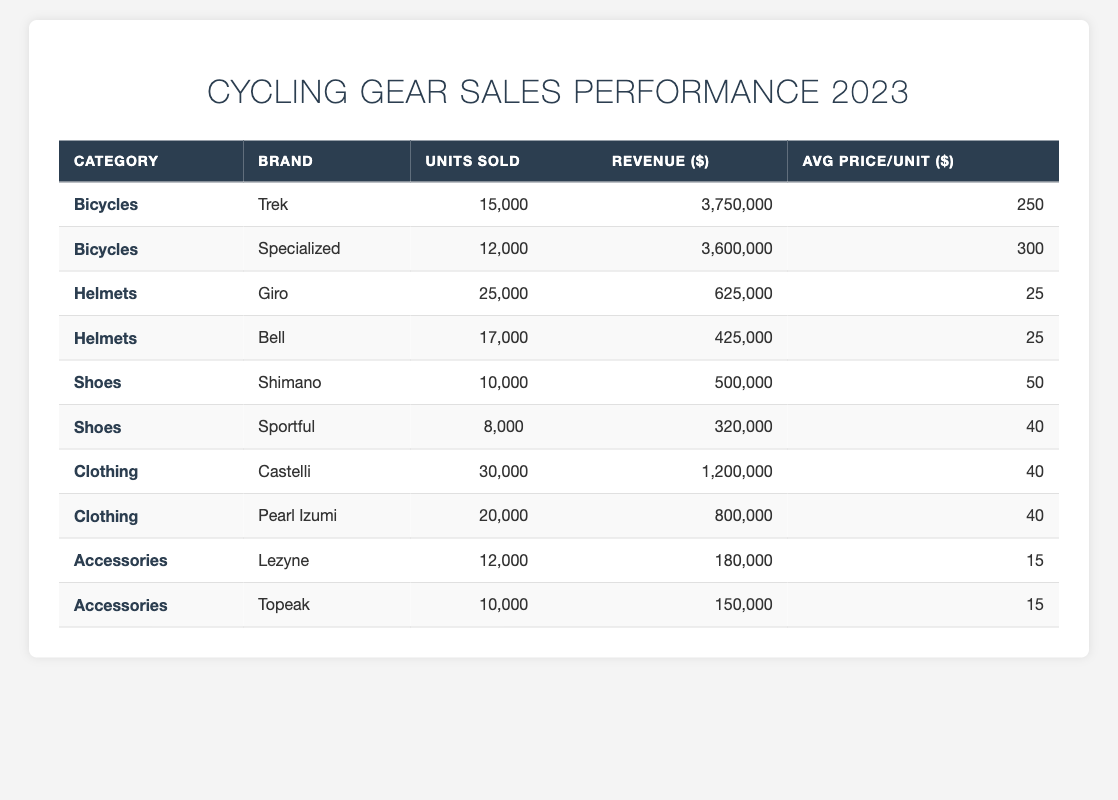What is the total revenue generated from bicycle sales? The revenues for bicycles sold are $3,750,000 (Trek) + $3,600,000 (Specialized) = $7,350,000.
Answer: $7,350,000 Which brand sold the most units of helmets? Giro sold 25,000 units, whereas Bell sold 17,000 units. Therefore, Giro sold the most helmets.
Answer: Giro What was the average price per unit for clothing? The average price for clothing can be calculated by summing the prices of both brands: (Castelli's $40 + Pearl Izumi's $40) / 2 = $40.
Answer: $40 How many more units of helmets were sold compared to shoes? A total of helmets sold is 25,000 (Giro) + 17,000 (Bell) = 42,000. For shoes, the total is 10,000 (Shimano) + 8,000 (Sportful) = 18,000. The difference is 42,000 - 18,000 = 24,000.
Answer: 24,000 Did the brand Shimano earn more revenue than Bell? Shimano's revenue is $500,000, while Bell's revenue is $425,000. Therefore, Shimano earned more.
Answer: Yes What is the percentage of total revenue contributed by clothing sales? Total revenue is $7,350,000 (Bicycles) + $625,000 (Helmets) + $500,000 (Shoes) + $1,200,000 (Clothing) + $180,000 (Accessories) = $9,855,000. Clothing revenue of $1,200,000 contributes (1,200,000 / 9,855,000) * 100 = 12.16%.
Answer: 12.16% Which category had the highest average price per unit, and what was it? Bicycles had an average price per unit of $250 (Trek) and $300 (Specialized). Helmets average $25 each, Shoes average $45, Clothing average $40, and Accessories average $15. The highest is $300 for Specialized.
Answer: $300 If you combine the units sold by Lezyne and Topeak, how many units would that be? Lezyne sold 12,000 units and Topeak sold 10,000 units. Combined, they sold 12,000 + 10,000 = 22,000 units.
Answer: 22,000 Is the revenue from shoes greater than the revenue from accessories? Shoes generated $500,000, while Accessories generated $180,000. Therefore, shoes generated more revenue.
Answer: Yes What is the relationship between units sold for Castelli and Pearl Izumi in comparison to units sold for Shimano? Castelli sold 30,000 units and Pearl Izumi sold 20,000 units. Combined, that's 50,000 units, which is greater than Shimano's 10,000 units.
Answer: Greater What is the total number of units sold across all categories? The total is 15,000 (Trek) + 12,000 (Specialized) + 25,000 (Giro) + 17,000 (Bell) + 10,000 (Shimano) + 8,000 (Sportful) + 30,000 (Castelli) + 20,000 (Pearl Izumi) + 12,000 (Lezyne) + 10,000 (Topeak) =  100,000.
Answer: 100,000 